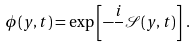<formula> <loc_0><loc_0><loc_500><loc_500>\phi ( y , t ) = \exp \left [ - \frac { i } { } \mathcal { S } ( y , t ) \right ] \, .</formula> 